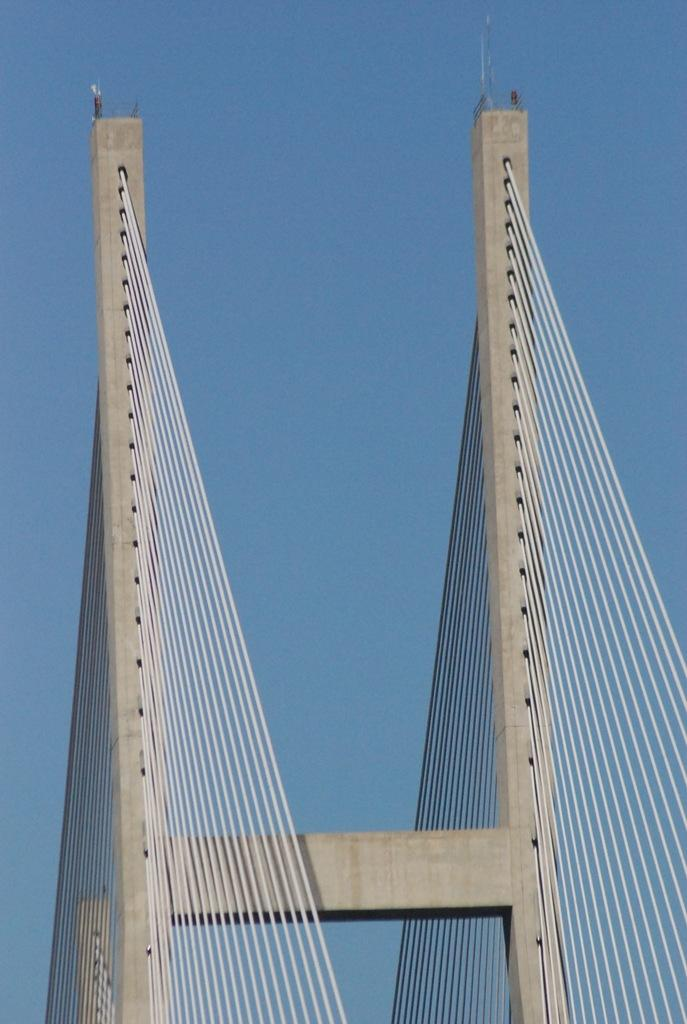What type of bridge is shown in the image? There is a cable stayed bridge in the image. What can be seen in the background of the image? The sky is visible in the image. How many beetles can be seen crawling on the bushes in the image? There are no beetles or bushes present in the image; it features a cable stayed bridge and the sky. 